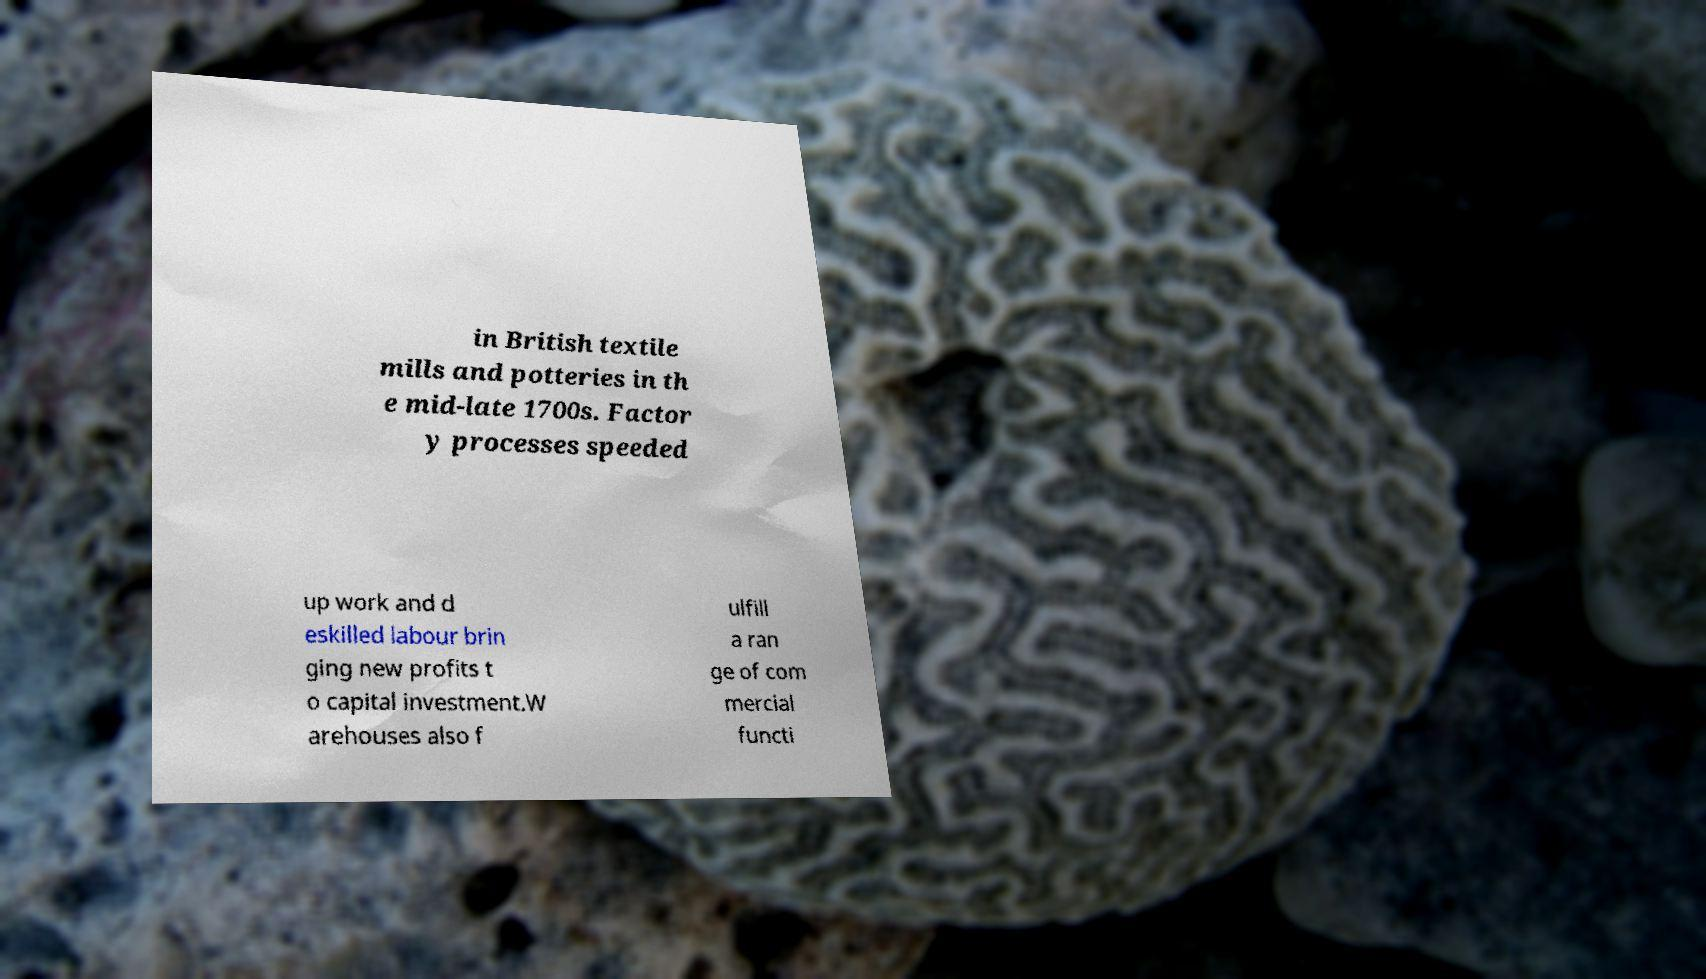Please read and relay the text visible in this image. What does it say? in British textile mills and potteries in th e mid-late 1700s. Factor y processes speeded up work and d eskilled labour brin ging new profits t o capital investment.W arehouses also f ulfill a ran ge of com mercial functi 